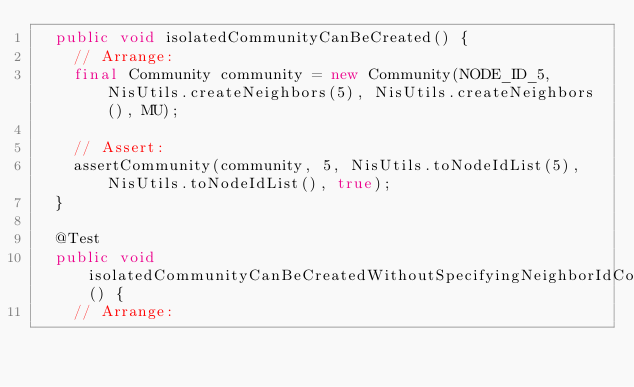Convert code to text. <code><loc_0><loc_0><loc_500><loc_500><_Java_>	public void isolatedCommunityCanBeCreated() {
		// Arrange:
		final Community community = new Community(NODE_ID_5, NisUtils.createNeighbors(5), NisUtils.createNeighbors(), MU);

		// Assert:
		assertCommunity(community, 5, NisUtils.toNodeIdList(5), NisUtils.toNodeIdList(), true);
	}

	@Test
	public void isolatedCommunityCanBeCreatedWithoutSpecifyingNeighborIdCollections() {
		// Arrange:</code> 